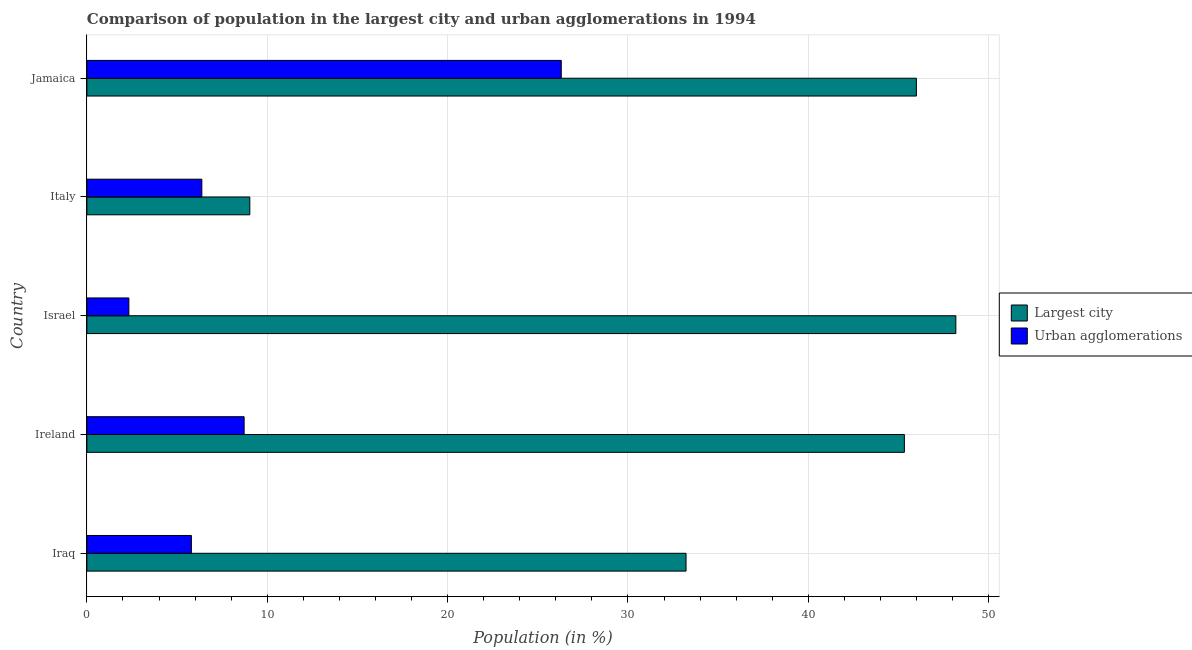How many different coloured bars are there?
Offer a very short reply. 2. How many groups of bars are there?
Offer a terse response. 5. Are the number of bars on each tick of the Y-axis equal?
Keep it short and to the point. Yes. How many bars are there on the 5th tick from the top?
Offer a very short reply. 2. What is the label of the 1st group of bars from the top?
Ensure brevity in your answer.  Jamaica. In how many cases, is the number of bars for a given country not equal to the number of legend labels?
Your answer should be compact. 0. What is the population in urban agglomerations in Iraq?
Offer a very short reply. 5.79. Across all countries, what is the maximum population in urban agglomerations?
Offer a terse response. 26.3. Across all countries, what is the minimum population in the largest city?
Provide a succinct answer. 9.03. In which country was the population in the largest city maximum?
Your answer should be compact. Israel. What is the total population in the largest city in the graph?
Offer a terse response. 181.75. What is the difference between the population in urban agglomerations in Ireland and that in Italy?
Your response must be concise. 2.35. What is the difference between the population in urban agglomerations in Israel and the population in the largest city in Ireland?
Your answer should be very brief. -43. What is the average population in urban agglomerations per country?
Your answer should be compact. 9.9. What is the difference between the population in urban agglomerations and population in the largest city in Italy?
Your answer should be very brief. -2.66. In how many countries, is the population in the largest city greater than 10 %?
Keep it short and to the point. 4. What is the ratio of the population in the largest city in Iraq to that in Jamaica?
Your response must be concise. 0.72. Is the population in urban agglomerations in Iraq less than that in Jamaica?
Provide a short and direct response. Yes. Is the difference between the population in the largest city in Israel and Jamaica greater than the difference between the population in urban agglomerations in Israel and Jamaica?
Give a very brief answer. Yes. What is the difference between the highest and the second highest population in the largest city?
Your response must be concise. 2.19. What is the difference between the highest and the lowest population in the largest city?
Provide a succinct answer. 39.15. Is the sum of the population in urban agglomerations in Iraq and Jamaica greater than the maximum population in the largest city across all countries?
Your response must be concise. No. What does the 1st bar from the top in Ireland represents?
Your response must be concise. Urban agglomerations. What does the 1st bar from the bottom in Ireland represents?
Provide a short and direct response. Largest city. How many countries are there in the graph?
Keep it short and to the point. 5. What is the difference between two consecutive major ticks on the X-axis?
Make the answer very short. 10. Are the values on the major ticks of X-axis written in scientific E-notation?
Provide a succinct answer. No. Does the graph contain any zero values?
Your answer should be very brief. No. Does the graph contain grids?
Offer a terse response. Yes. How many legend labels are there?
Give a very brief answer. 2. How are the legend labels stacked?
Offer a very short reply. Vertical. What is the title of the graph?
Offer a very short reply. Comparison of population in the largest city and urban agglomerations in 1994. Does "Sanitation services" appear as one of the legend labels in the graph?
Make the answer very short. No. What is the label or title of the X-axis?
Provide a short and direct response. Population (in %). What is the label or title of the Y-axis?
Provide a succinct answer. Country. What is the Population (in %) in Largest city in Iraq?
Provide a succinct answer. 33.22. What is the Population (in %) in Urban agglomerations in Iraq?
Your answer should be very brief. 5.79. What is the Population (in %) in Largest city in Ireland?
Offer a terse response. 45.33. What is the Population (in %) of Urban agglomerations in Ireland?
Provide a succinct answer. 8.72. What is the Population (in %) in Largest city in Israel?
Provide a short and direct response. 48.18. What is the Population (in %) of Urban agglomerations in Israel?
Provide a succinct answer. 2.33. What is the Population (in %) of Largest city in Italy?
Your response must be concise. 9.03. What is the Population (in %) in Urban agglomerations in Italy?
Make the answer very short. 6.37. What is the Population (in %) in Largest city in Jamaica?
Your response must be concise. 45.99. What is the Population (in %) in Urban agglomerations in Jamaica?
Keep it short and to the point. 26.3. Across all countries, what is the maximum Population (in %) in Largest city?
Provide a succinct answer. 48.18. Across all countries, what is the maximum Population (in %) of Urban agglomerations?
Give a very brief answer. 26.3. Across all countries, what is the minimum Population (in %) in Largest city?
Your answer should be compact. 9.03. Across all countries, what is the minimum Population (in %) of Urban agglomerations?
Your response must be concise. 2.33. What is the total Population (in %) of Largest city in the graph?
Your response must be concise. 181.75. What is the total Population (in %) of Urban agglomerations in the graph?
Your answer should be compact. 49.51. What is the difference between the Population (in %) of Largest city in Iraq and that in Ireland?
Your response must be concise. -12.1. What is the difference between the Population (in %) in Urban agglomerations in Iraq and that in Ireland?
Keep it short and to the point. -2.92. What is the difference between the Population (in %) of Largest city in Iraq and that in Israel?
Make the answer very short. -14.96. What is the difference between the Population (in %) of Urban agglomerations in Iraq and that in Israel?
Your answer should be very brief. 3.46. What is the difference between the Population (in %) in Largest city in Iraq and that in Italy?
Make the answer very short. 24.19. What is the difference between the Population (in %) of Urban agglomerations in Iraq and that in Italy?
Your response must be concise. -0.58. What is the difference between the Population (in %) in Largest city in Iraq and that in Jamaica?
Your response must be concise. -12.77. What is the difference between the Population (in %) of Urban agglomerations in Iraq and that in Jamaica?
Give a very brief answer. -20.51. What is the difference between the Population (in %) in Largest city in Ireland and that in Israel?
Make the answer very short. -2.85. What is the difference between the Population (in %) in Urban agglomerations in Ireland and that in Israel?
Provide a short and direct response. 6.39. What is the difference between the Population (in %) of Largest city in Ireland and that in Italy?
Provide a succinct answer. 36.29. What is the difference between the Population (in %) of Urban agglomerations in Ireland and that in Italy?
Your answer should be compact. 2.34. What is the difference between the Population (in %) of Largest city in Ireland and that in Jamaica?
Your response must be concise. -0.67. What is the difference between the Population (in %) in Urban agglomerations in Ireland and that in Jamaica?
Your answer should be very brief. -17.58. What is the difference between the Population (in %) of Largest city in Israel and that in Italy?
Offer a very short reply. 39.15. What is the difference between the Population (in %) of Urban agglomerations in Israel and that in Italy?
Make the answer very short. -4.05. What is the difference between the Population (in %) in Largest city in Israel and that in Jamaica?
Give a very brief answer. 2.19. What is the difference between the Population (in %) in Urban agglomerations in Israel and that in Jamaica?
Give a very brief answer. -23.97. What is the difference between the Population (in %) of Largest city in Italy and that in Jamaica?
Offer a very short reply. -36.96. What is the difference between the Population (in %) of Urban agglomerations in Italy and that in Jamaica?
Give a very brief answer. -19.93. What is the difference between the Population (in %) in Largest city in Iraq and the Population (in %) in Urban agglomerations in Ireland?
Give a very brief answer. 24.5. What is the difference between the Population (in %) of Largest city in Iraq and the Population (in %) of Urban agglomerations in Israel?
Provide a succinct answer. 30.89. What is the difference between the Population (in %) in Largest city in Iraq and the Population (in %) in Urban agglomerations in Italy?
Your response must be concise. 26.85. What is the difference between the Population (in %) in Largest city in Iraq and the Population (in %) in Urban agglomerations in Jamaica?
Offer a very short reply. 6.92. What is the difference between the Population (in %) of Largest city in Ireland and the Population (in %) of Urban agglomerations in Israel?
Keep it short and to the point. 43. What is the difference between the Population (in %) of Largest city in Ireland and the Population (in %) of Urban agglomerations in Italy?
Your answer should be compact. 38.95. What is the difference between the Population (in %) in Largest city in Ireland and the Population (in %) in Urban agglomerations in Jamaica?
Ensure brevity in your answer.  19.02. What is the difference between the Population (in %) in Largest city in Israel and the Population (in %) in Urban agglomerations in Italy?
Your answer should be very brief. 41.81. What is the difference between the Population (in %) of Largest city in Israel and the Population (in %) of Urban agglomerations in Jamaica?
Your response must be concise. 21.88. What is the difference between the Population (in %) of Largest city in Italy and the Population (in %) of Urban agglomerations in Jamaica?
Give a very brief answer. -17.27. What is the average Population (in %) of Largest city per country?
Offer a terse response. 36.35. What is the average Population (in %) of Urban agglomerations per country?
Provide a succinct answer. 9.9. What is the difference between the Population (in %) in Largest city and Population (in %) in Urban agglomerations in Iraq?
Provide a succinct answer. 27.43. What is the difference between the Population (in %) of Largest city and Population (in %) of Urban agglomerations in Ireland?
Your answer should be very brief. 36.61. What is the difference between the Population (in %) in Largest city and Population (in %) in Urban agglomerations in Israel?
Offer a terse response. 45.85. What is the difference between the Population (in %) in Largest city and Population (in %) in Urban agglomerations in Italy?
Your answer should be very brief. 2.66. What is the difference between the Population (in %) of Largest city and Population (in %) of Urban agglomerations in Jamaica?
Offer a terse response. 19.69. What is the ratio of the Population (in %) in Largest city in Iraq to that in Ireland?
Your response must be concise. 0.73. What is the ratio of the Population (in %) of Urban agglomerations in Iraq to that in Ireland?
Offer a terse response. 0.66. What is the ratio of the Population (in %) of Largest city in Iraq to that in Israel?
Your answer should be very brief. 0.69. What is the ratio of the Population (in %) of Urban agglomerations in Iraq to that in Israel?
Your answer should be compact. 2.49. What is the ratio of the Population (in %) of Largest city in Iraq to that in Italy?
Offer a terse response. 3.68. What is the ratio of the Population (in %) of Urban agglomerations in Iraq to that in Italy?
Your response must be concise. 0.91. What is the ratio of the Population (in %) of Largest city in Iraq to that in Jamaica?
Your answer should be very brief. 0.72. What is the ratio of the Population (in %) in Urban agglomerations in Iraq to that in Jamaica?
Give a very brief answer. 0.22. What is the ratio of the Population (in %) in Largest city in Ireland to that in Israel?
Offer a very short reply. 0.94. What is the ratio of the Population (in %) of Urban agglomerations in Ireland to that in Israel?
Offer a terse response. 3.74. What is the ratio of the Population (in %) of Largest city in Ireland to that in Italy?
Your answer should be very brief. 5.02. What is the ratio of the Population (in %) of Urban agglomerations in Ireland to that in Italy?
Your answer should be very brief. 1.37. What is the ratio of the Population (in %) of Largest city in Ireland to that in Jamaica?
Make the answer very short. 0.99. What is the ratio of the Population (in %) of Urban agglomerations in Ireland to that in Jamaica?
Your answer should be very brief. 0.33. What is the ratio of the Population (in %) in Largest city in Israel to that in Italy?
Offer a very short reply. 5.33. What is the ratio of the Population (in %) in Urban agglomerations in Israel to that in Italy?
Your answer should be very brief. 0.37. What is the ratio of the Population (in %) in Largest city in Israel to that in Jamaica?
Provide a short and direct response. 1.05. What is the ratio of the Population (in %) of Urban agglomerations in Israel to that in Jamaica?
Offer a terse response. 0.09. What is the ratio of the Population (in %) of Largest city in Italy to that in Jamaica?
Provide a short and direct response. 0.2. What is the ratio of the Population (in %) in Urban agglomerations in Italy to that in Jamaica?
Provide a short and direct response. 0.24. What is the difference between the highest and the second highest Population (in %) in Largest city?
Provide a succinct answer. 2.19. What is the difference between the highest and the second highest Population (in %) in Urban agglomerations?
Your answer should be very brief. 17.58. What is the difference between the highest and the lowest Population (in %) of Largest city?
Your response must be concise. 39.15. What is the difference between the highest and the lowest Population (in %) of Urban agglomerations?
Your answer should be very brief. 23.97. 